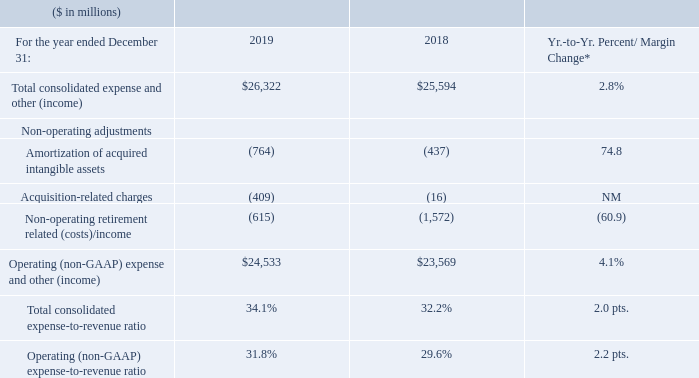Total Expense and Other (Income)
* 2019 results were impacted by Red Hat purchase accounting and acquisition-related activity.
The following Red Hat-related expenses were included in 2019 total consolidated expense and other (income), with no corresponding expense in the prior-year: Red Hat operational spending, interest expense from debt issuances to fund the acquisition and other acquisition-related activity, including: amortization of acquired intangible assets, retention and legal and advisory fees associated with the transaction.
Total expense and other (income) increased 2.8 percent in 2019 versus the prior year primarily driven by higher spending including Red Hat operational spending and investments in software and systems innovation, higher interest expense, non-operating acquisition-related activity associated with the Red Hat transaction and lower IP income, partially offset by lower non-operating retirement-related costs, divesture-related activity (gains on divestitures and lower spending) and the effects of currency. Total operating (non-GAAP) expense and other (income) increased 4.1 percent year to year, driven primarily by the factors above excluding the higher non-operating acquisition related activity and lower non-operating retirement-related costs described above.
What activity impacted the 2019 results? 2019 results were impacted by red hat purchase accounting and acquisition-related activity. What expenses were included in 2019 total consolidated expenses and other (income)? Red hat operational spending, interest expense from debt issuances to fund the acquisition and other acquisition-related activity, including: amortization of acquired intangible assets, retention and legal and advisory fees associated with the transaction. What caused the increase in the total operating expenses? Total operating (non-gaap) expense and other (income) increased 4.1 percent year to year, driven primarily by the factors above excluding the higher non-operating acquisition related activity and lower non-operating retirement-related costs described above. What is the average of Total consolidated expense and other (income)?
Answer scale should be: million. (26,322 + 25,594) / 2
Answer: 25958. What is the increase / (decrease) in the Amortization of acquired intangible assets from 2018 to 2019?
Answer scale should be: million. -764 - ( -437)
Answer: -327. What is the increase / (decrease) in the Operating (non-GAAP) expense and other (income) from 2018 to 2019?
Answer scale should be: million. 24,533 - 23,569
Answer: 964. 